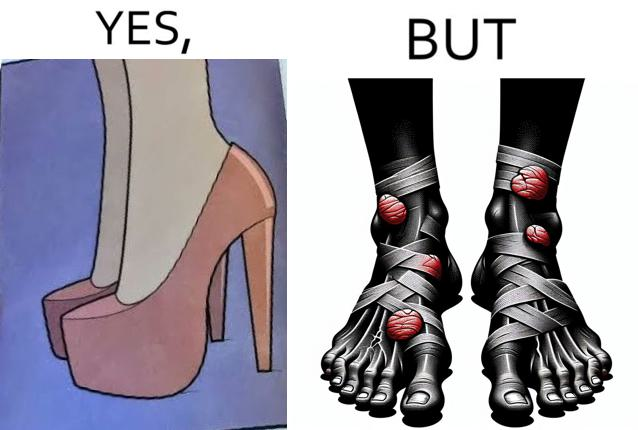Does this image contain satire or humor? Yes, this image is satirical. 